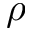Convert formula to latex. <formula><loc_0><loc_0><loc_500><loc_500>\rho</formula> 